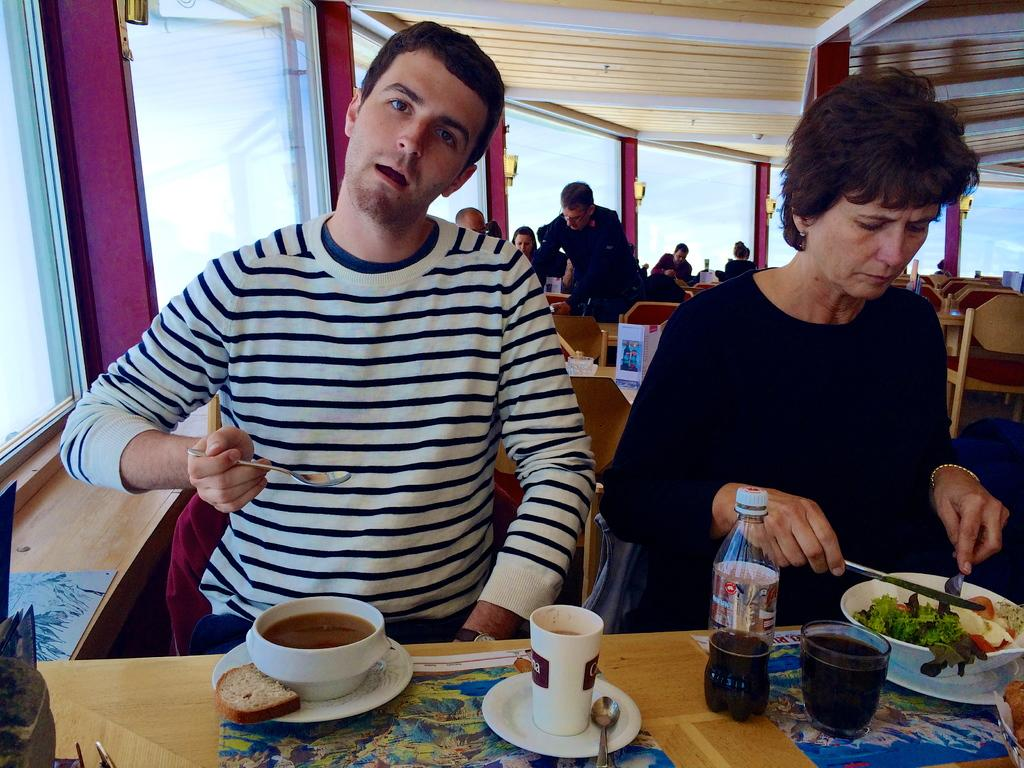What are the people in the image doing? There are people seated on chairs in the image, and a person is serving food. Can you describe the actions of the man and woman in the image? A man and a woman are taking their food in the image. What can be seen on the table in the image? There is a water bottle and cups on the table in the image. What type of letters are being passed between the man and woman in the image? There are no letters present in the image; the man and woman are taking their food. Can you describe the boundary between the man and woman in the image? There is no boundary between the man and woman in the image; they are both seated at a table. 